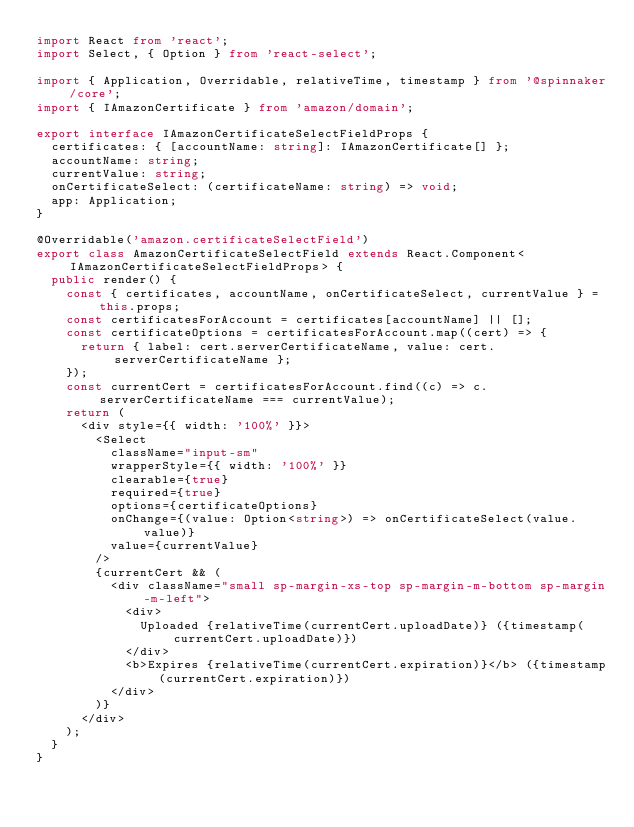Convert code to text. <code><loc_0><loc_0><loc_500><loc_500><_TypeScript_>import React from 'react';
import Select, { Option } from 'react-select';

import { Application, Overridable, relativeTime, timestamp } from '@spinnaker/core';
import { IAmazonCertificate } from 'amazon/domain';

export interface IAmazonCertificateSelectFieldProps {
  certificates: { [accountName: string]: IAmazonCertificate[] };
  accountName: string;
  currentValue: string;
  onCertificateSelect: (certificateName: string) => void;
  app: Application;
}

@Overridable('amazon.certificateSelectField')
export class AmazonCertificateSelectField extends React.Component<IAmazonCertificateSelectFieldProps> {
  public render() {
    const { certificates, accountName, onCertificateSelect, currentValue } = this.props;
    const certificatesForAccount = certificates[accountName] || [];
    const certificateOptions = certificatesForAccount.map((cert) => {
      return { label: cert.serverCertificateName, value: cert.serverCertificateName };
    });
    const currentCert = certificatesForAccount.find((c) => c.serverCertificateName === currentValue);
    return (
      <div style={{ width: '100%' }}>
        <Select
          className="input-sm"
          wrapperStyle={{ width: '100%' }}
          clearable={true}
          required={true}
          options={certificateOptions}
          onChange={(value: Option<string>) => onCertificateSelect(value.value)}
          value={currentValue}
        />
        {currentCert && (
          <div className="small sp-margin-xs-top sp-margin-m-bottom sp-margin-m-left">
            <div>
              Uploaded {relativeTime(currentCert.uploadDate)} ({timestamp(currentCert.uploadDate)})
            </div>
            <b>Expires {relativeTime(currentCert.expiration)}</b> ({timestamp(currentCert.expiration)})
          </div>
        )}
      </div>
    );
  }
}
</code> 